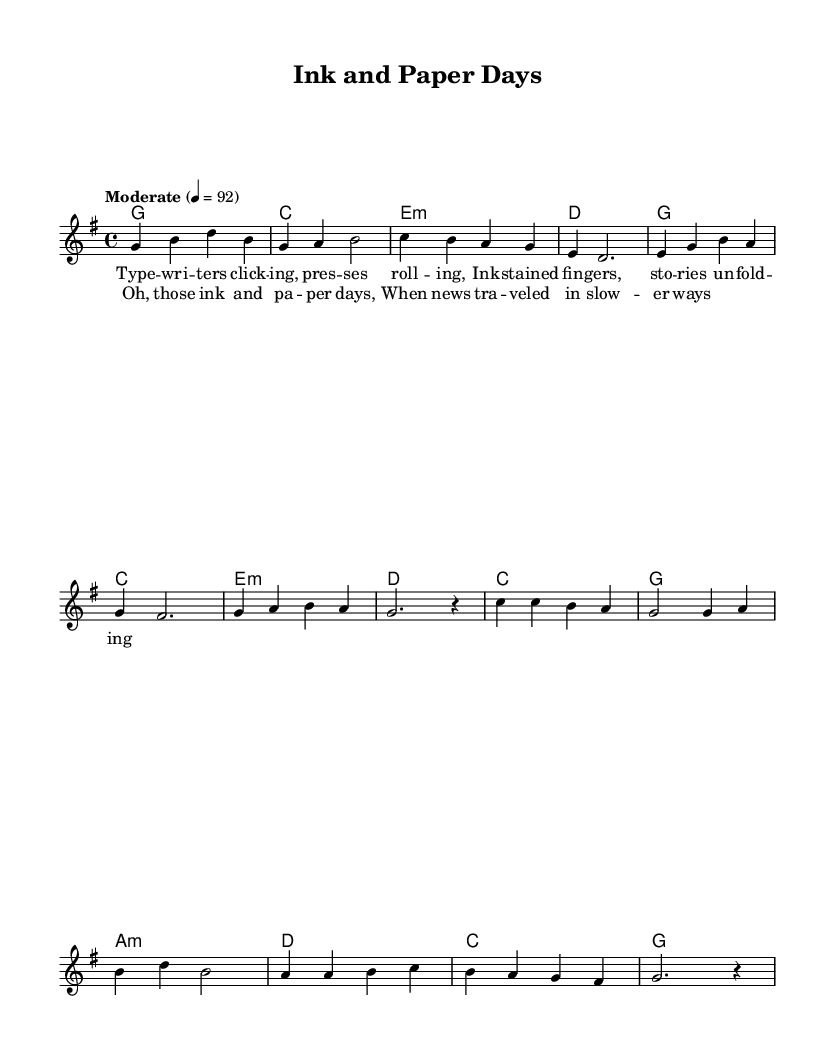What is the key signature of this music? The key signature indicates a G major key, which contains one sharp (F#). This is determined by observing the sharp sign noted on the staff.
Answer: G major What is the time signature of this music? The time signature is 4/4, meaning there are four beats per measure and the quarter note gets one beat. This can be identified from the time signature notation at the beginning of the score.
Answer: 4/4 What is the tempo marking for this piece? The tempo marking is "Moderate" at a quarter note equals 92. This provides instructions on how fast to play the music, noted at the start of the score.
Answer: Moderate 4 = 92 How many measures are there in the verse? The verse consists of eight measures, which can be counted from the start to the end of the verse section in the melody.
Answer: 8 measures Which chord appears at the beginning of the chorus? The first chord in the chorus section is C major, as indicated in the chord symbols placed above the melody.
Answer: C What is the lyrical theme of the song? The lyrics reflect on the nostalgia of "ink and paper days," highlighting how stories were told in the past. The lyrics describe writers, printing presses, and a slower-paced news cycle.
Answer: Nostalgia How does the harmony change in the chorus compared to the verse? The harmony in the chorus includes C major, G major, A minor, and D major, while the verse primarily uses G major, C major, and E minor. This indicates a slight variation in chord structure to enhance the contrast between sections.
Answer: Harmonies change 